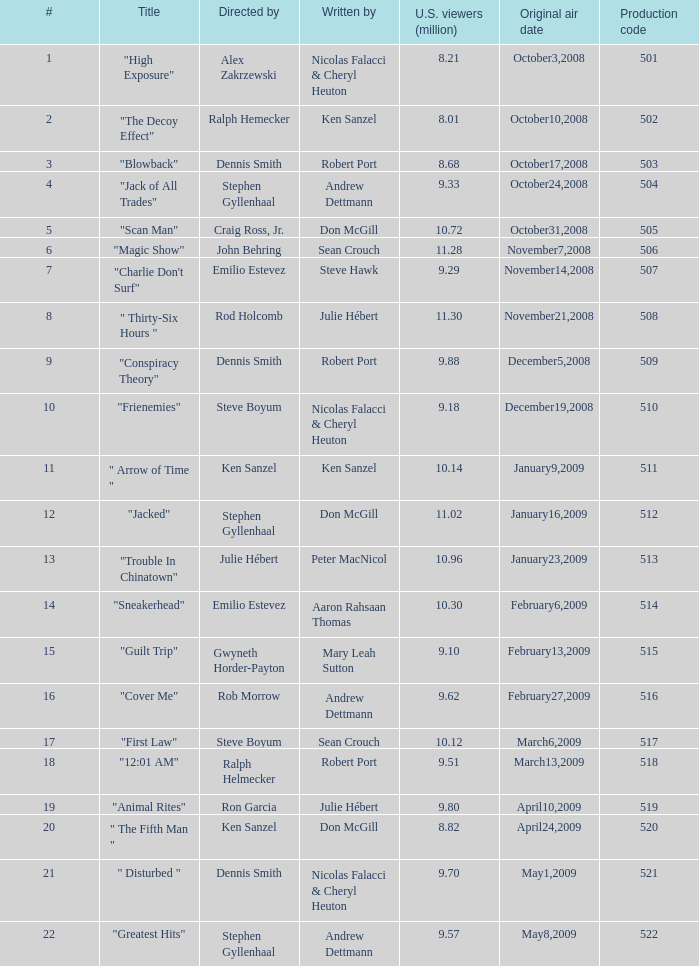How many times did episode 6 originally air? 1.0. Can you parse all the data within this table? {'header': ['#', 'Title', 'Directed by', 'Written by', 'U.S. viewers (million)', 'Original air date', 'Production code'], 'rows': [['1', '"High Exposure"', 'Alex Zakrzewski', 'Nicolas Falacci & Cheryl Heuton', '8.21', 'October3,2008', '501'], ['2', '"The Decoy Effect"', 'Ralph Hemecker', 'Ken Sanzel', '8.01', 'October10,2008', '502'], ['3', '"Blowback"', 'Dennis Smith', 'Robert Port', '8.68', 'October17,2008', '503'], ['4', '"Jack of All Trades"', 'Stephen Gyllenhaal', 'Andrew Dettmann', '9.33', 'October24,2008', '504'], ['5', '"Scan Man"', 'Craig Ross, Jr.', 'Don McGill', '10.72', 'October31,2008', '505'], ['6', '"Magic Show"', 'John Behring', 'Sean Crouch', '11.28', 'November7,2008', '506'], ['7', '"Charlie Don\'t Surf"', 'Emilio Estevez', 'Steve Hawk', '9.29', 'November14,2008', '507'], ['8', '" Thirty-Six Hours "', 'Rod Holcomb', 'Julie Hébert', '11.30', 'November21,2008', '508'], ['9', '"Conspiracy Theory"', 'Dennis Smith', 'Robert Port', '9.88', 'December5,2008', '509'], ['10', '"Frienemies"', 'Steve Boyum', 'Nicolas Falacci & Cheryl Heuton', '9.18', 'December19,2008', '510'], ['11', '" Arrow of Time "', 'Ken Sanzel', 'Ken Sanzel', '10.14', 'January9,2009', '511'], ['12', '"Jacked"', 'Stephen Gyllenhaal', 'Don McGill', '11.02', 'January16,2009', '512'], ['13', '"Trouble In Chinatown"', 'Julie Hébert', 'Peter MacNicol', '10.96', 'January23,2009', '513'], ['14', '"Sneakerhead"', 'Emilio Estevez', 'Aaron Rahsaan Thomas', '10.30', 'February6,2009', '514'], ['15', '"Guilt Trip"', 'Gwyneth Horder-Payton', 'Mary Leah Sutton', '9.10', 'February13,2009', '515'], ['16', '"Cover Me"', 'Rob Morrow', 'Andrew Dettmann', '9.62', 'February27,2009', '516'], ['17', '"First Law"', 'Steve Boyum', 'Sean Crouch', '10.12', 'March6,2009', '517'], ['18', '"12:01 AM"', 'Ralph Helmecker', 'Robert Port', '9.51', 'March13,2009', '518'], ['19', '"Animal Rites"', 'Ron Garcia', 'Julie Hébert', '9.80', 'April10,2009', '519'], ['20', '" The Fifth Man "', 'Ken Sanzel', 'Don McGill', '8.82', 'April24,2009', '520'], ['21', '" Disturbed "', 'Dennis Smith', 'Nicolas Falacci & Cheryl Heuton', '9.70', 'May1,2009', '521'], ['22', '"Greatest Hits"', 'Stephen Gyllenhaal', 'Andrew Dettmann', '9.57', 'May8,2009', '522']]} 